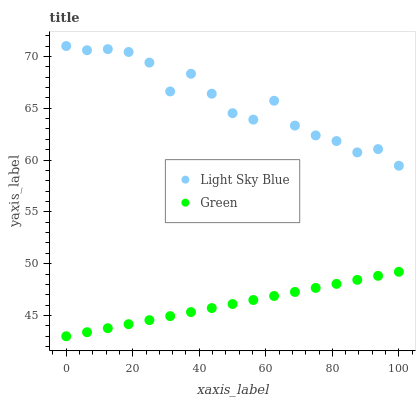Does Green have the minimum area under the curve?
Answer yes or no. Yes. Does Light Sky Blue have the maximum area under the curve?
Answer yes or no. Yes. Does Green have the maximum area under the curve?
Answer yes or no. No. Is Green the smoothest?
Answer yes or no. Yes. Is Light Sky Blue the roughest?
Answer yes or no. Yes. Is Green the roughest?
Answer yes or no. No. Does Green have the lowest value?
Answer yes or no. Yes. Does Light Sky Blue have the highest value?
Answer yes or no. Yes. Does Green have the highest value?
Answer yes or no. No. Is Green less than Light Sky Blue?
Answer yes or no. Yes. Is Light Sky Blue greater than Green?
Answer yes or no. Yes. Does Green intersect Light Sky Blue?
Answer yes or no. No. 